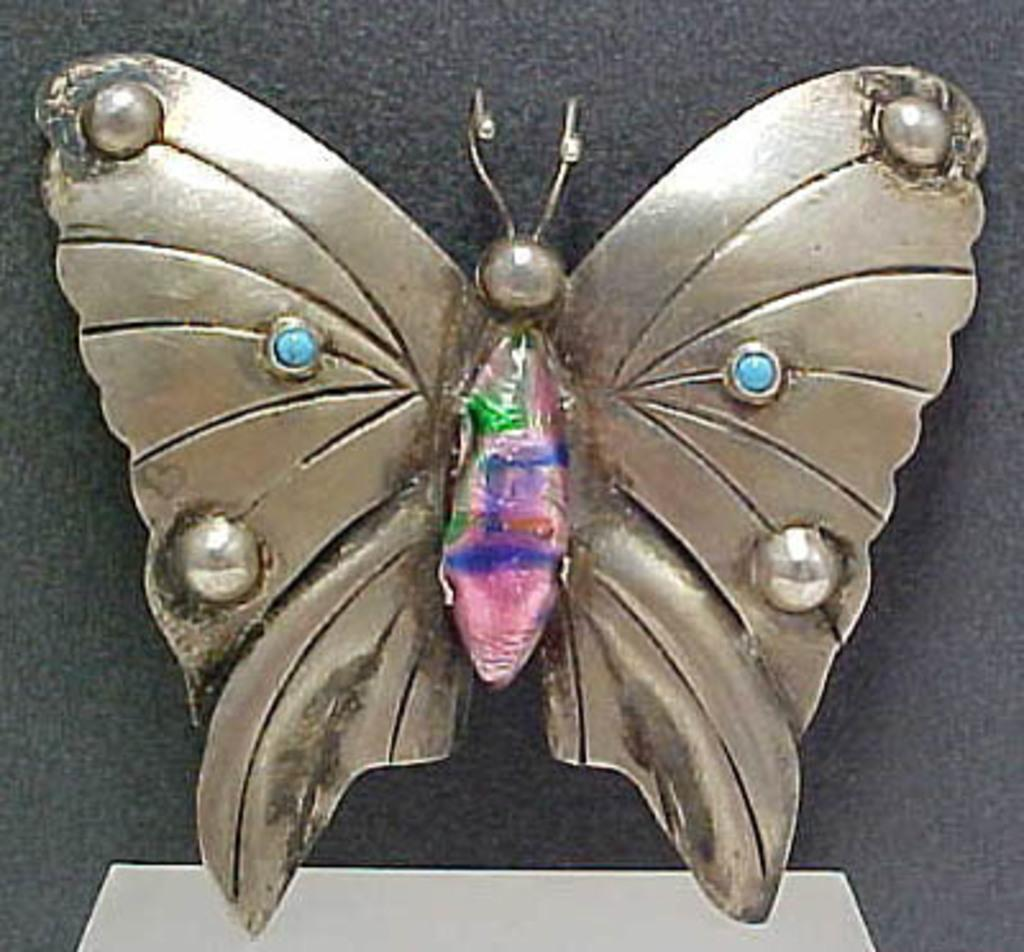What is the main subject of the image? The main subject of the image is a butterfly. What is the butterfly made of? The butterfly is made up of metal. What colors can be seen on the butterfly? The butterfly has blue, purple, pink, green, and brown colors. What is the color of the background in the image? The background of the image is black. What type of wine is being served to the girl in the image? There is no girl or wine present in the image; it features a metal butterfly with a black background. 